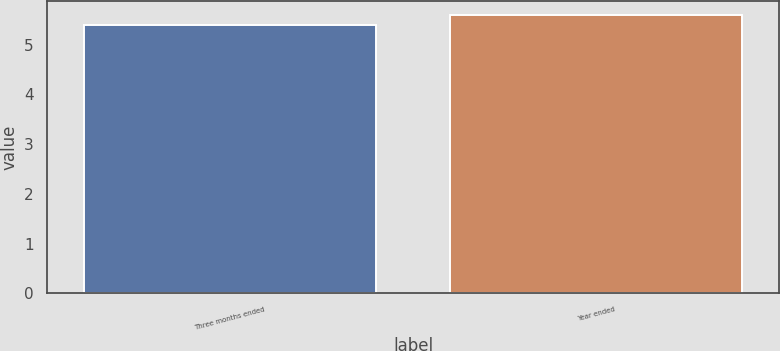<chart> <loc_0><loc_0><loc_500><loc_500><bar_chart><fcel>Three months ended<fcel>Year ended<nl><fcel>5.4<fcel>5.6<nl></chart> 